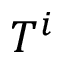Convert formula to latex. <formula><loc_0><loc_0><loc_500><loc_500>T ^ { i }</formula> 